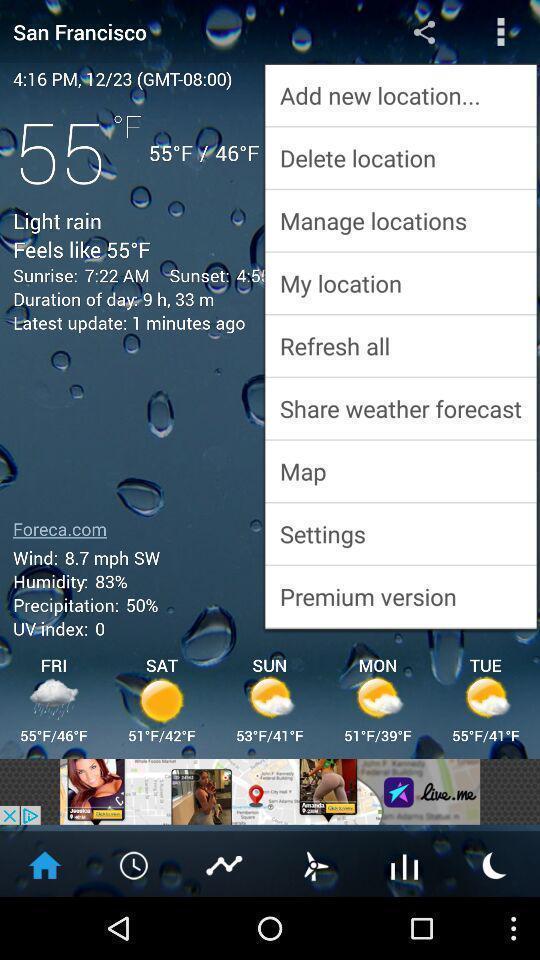Describe the visual elements of this screenshot. Page showing weather reports. 